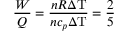Convert formula to latex. <formula><loc_0><loc_0><loc_500><loc_500>{ \frac { W } { Q } } = { \frac { n R \Delta T } { n c _ { p } \Delta T } } = { \frac { 2 } { 5 } }</formula> 